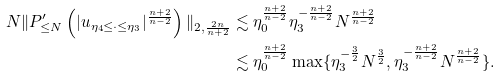Convert formula to latex. <formula><loc_0><loc_0><loc_500><loc_500>N \| P _ { \leq N } ^ { \prime } \left ( | u _ { \eta _ { 4 } \leq \cdot \leq \eta _ { 3 } } | ^ { \frac { n + 2 } { n - 2 } } \right ) \| _ { 2 , \frac { 2 n } { n + 2 } } & \lesssim \eta _ { 0 } ^ { \frac { n + 2 } { n - 2 } } \eta _ { 3 } ^ { - \frac { n + 2 } { n - 2 } } N ^ { \frac { n + 2 } { n - 2 } } \\ & \lesssim \eta _ { 0 } ^ { \frac { n + 2 } { n - 2 } } \max \{ \eta _ { 3 } ^ { - \frac { 3 } { 2 } } N ^ { \frac { 3 } { 2 } } , \eta _ { 3 } ^ { - \frac { n + 2 } { n - 2 } } N ^ { \frac { n + 2 } { n - 2 } } \} .</formula> 